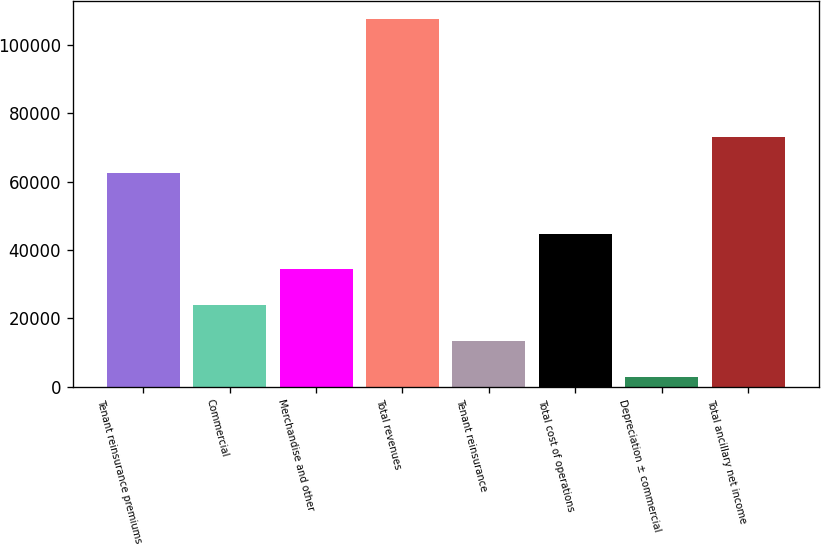Convert chart. <chart><loc_0><loc_0><loc_500><loc_500><bar_chart><fcel>Tenant reinsurance premiums<fcel>Commercial<fcel>Merchandise and other<fcel>Total revenues<fcel>Tenant reinsurance<fcel>Total cost of operations<fcel>Depreciation ± commercial<fcel>Total ancillary net income<nl><fcel>62644<fcel>23885.8<fcel>34349.7<fcel>107597<fcel>13421.9<fcel>44813.6<fcel>2958<fcel>73107.9<nl></chart> 